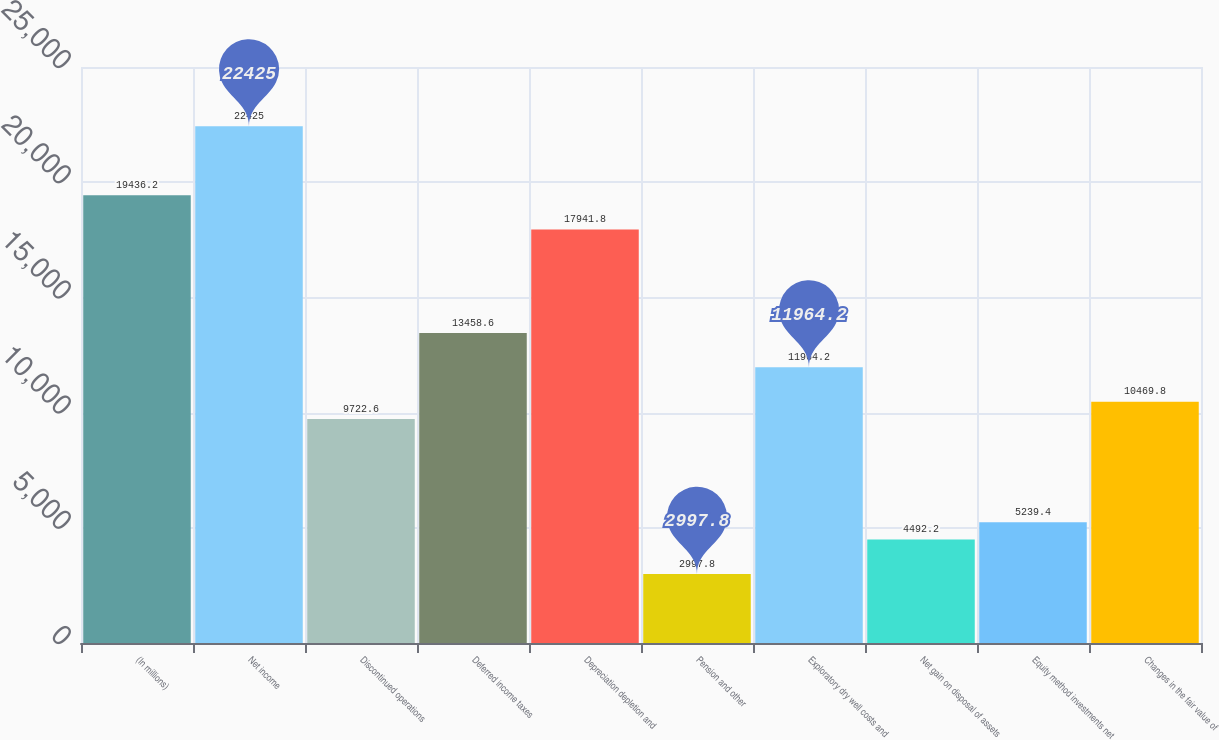<chart> <loc_0><loc_0><loc_500><loc_500><bar_chart><fcel>(In millions)<fcel>Net income<fcel>Discontinued operations<fcel>Deferred income taxes<fcel>Depreciation depletion and<fcel>Pension and other<fcel>Exploratory dry well costs and<fcel>Net gain on disposal of assets<fcel>Equity method investments net<fcel>Changes in the fair value of<nl><fcel>19436.2<fcel>22425<fcel>9722.6<fcel>13458.6<fcel>17941.8<fcel>2997.8<fcel>11964.2<fcel>4492.2<fcel>5239.4<fcel>10469.8<nl></chart> 